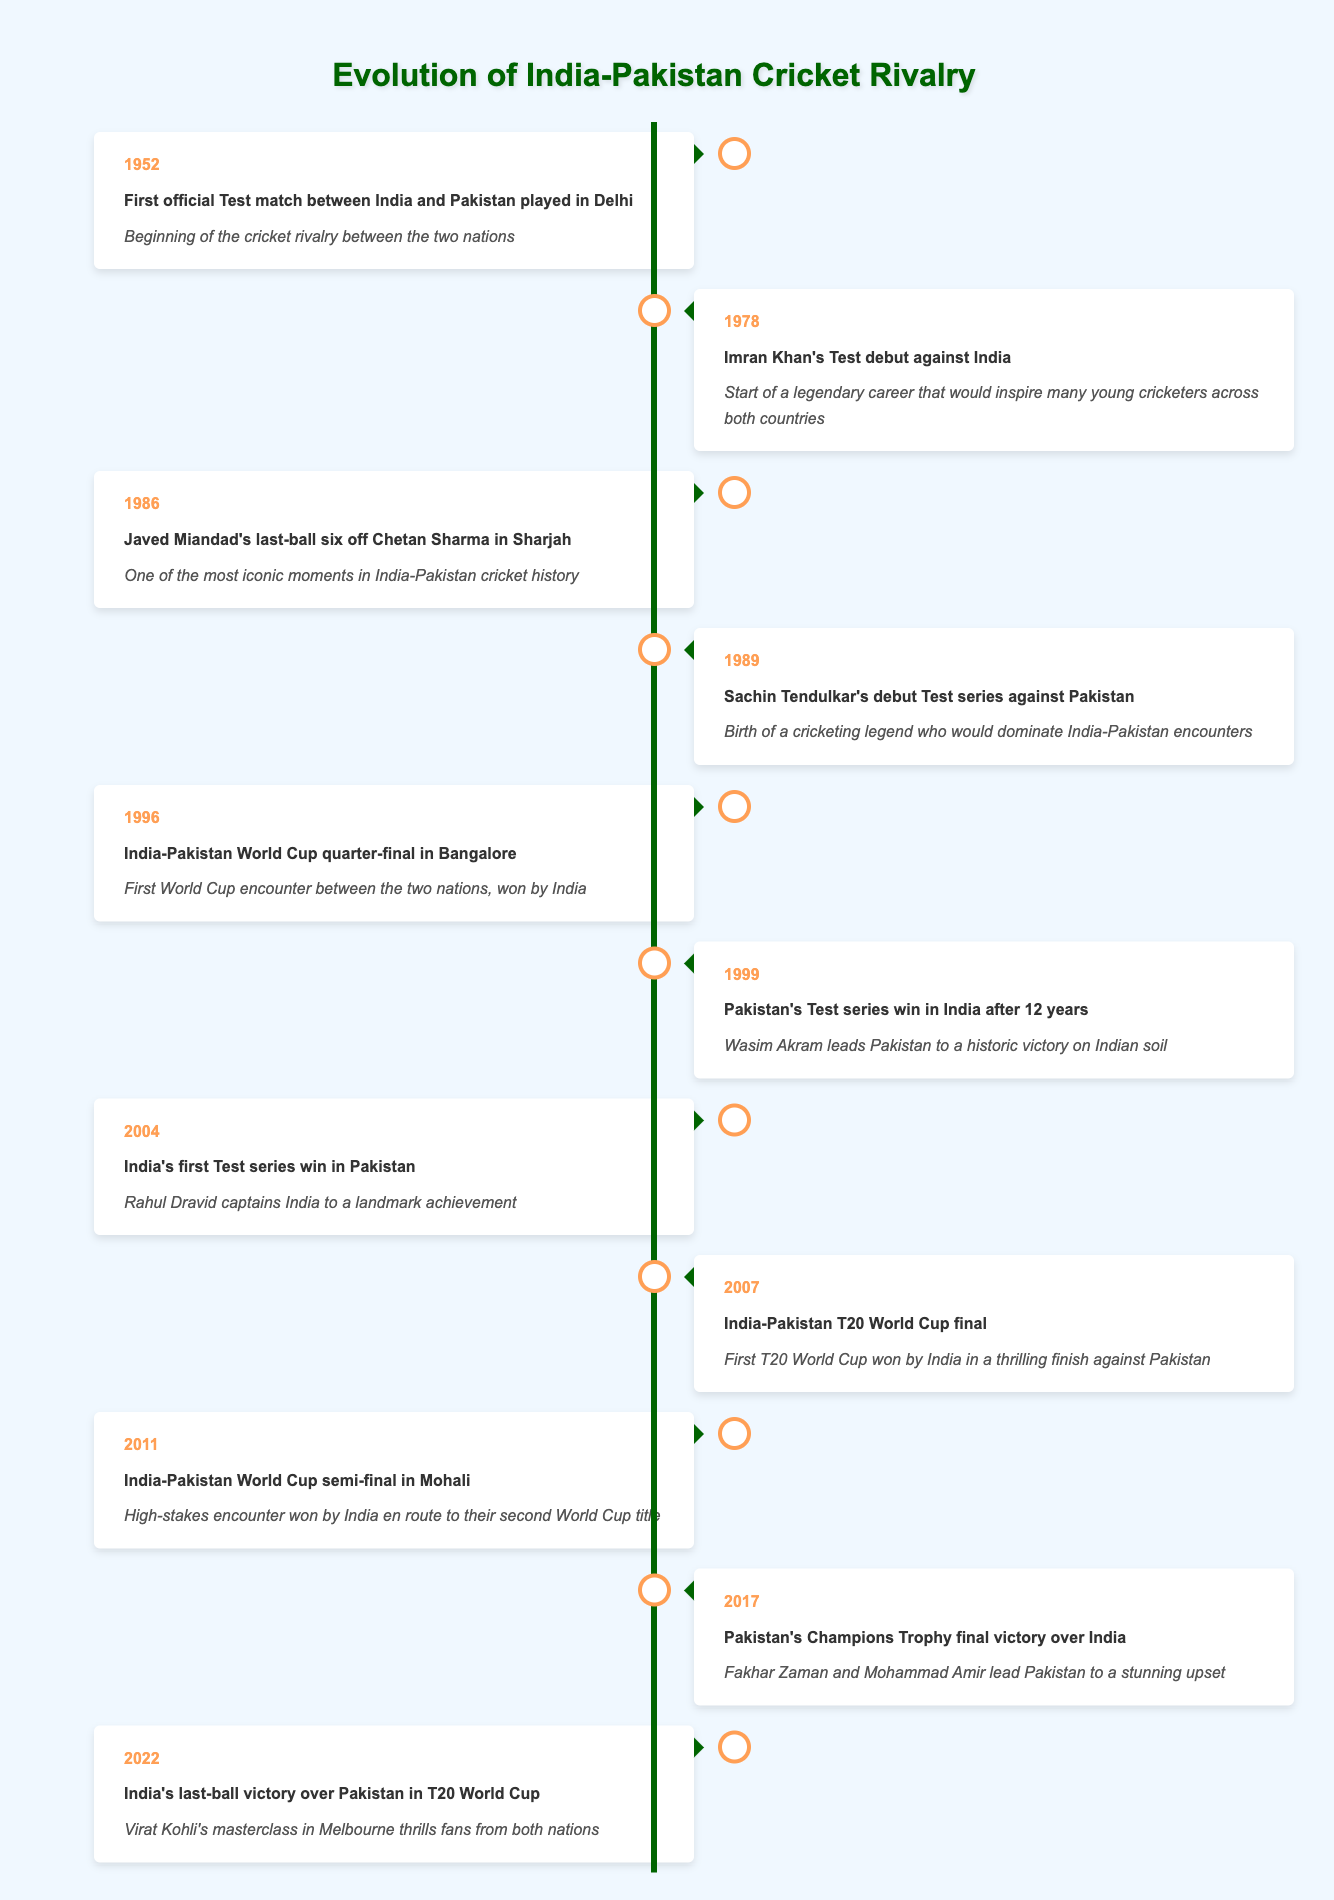What year did the first official Test match between India and Pakistan take place? The table indicates that the first official Test match between India and Pakistan was played in 1952. This information is listed in the timeline.
Answer: 1952 Who hit the last-ball six off Chetan Sharma in 1986? The timeline specifies that Javed Miandad hit the last-ball six off Chetan Sharma in 1986, making it a memorable moment in cricket history.
Answer: Javed Miandad Was Sachin Tendulkar's debut Test series against Pakistan before or after 1989? Referring to the table, Sachin Tendulkar's debut Test series against Pakistan is listed under the year 1989, which indicates that it took place in that year.
Answer: After How many years passed between India's first Test series win in Pakistan and Pakistan's Champions Trophy final victory over India? From the table, India's first Test series win in Pakistan occurred in 2004 and Pakistan's victory in the Champions Trophy final was in 2017. Therefore, 2017 - 2004 = 13 years passed between these events.
Answer: 13 In the year 1996, which match was held and what was its significance? The table shows that in 1996, the India-Pakistan World Cup quarter-final took place in Bangalore, and it was significant as it was the first World Cup encounter between the two nations, which India won.
Answer: India-Pakistan World Cup quarter-final, significance: first World Cup encounter won by India What was the outcome of the 2007 T20 World Cup final between India and Pakistan? The 2007 T20 World Cup final is described in the timeline as being won by India in a thrilling finish against Pakistan. This shows that India emerged victorious in that match.
Answer: India won List the years when India and Pakistan faced each other in World Cup matches. The table lists two World Cup matches between India and Pakistan: 1996 (quarter-final) and 2011 (semi-final). Thus, both encounters occurred in those years of the World Cups.
Answer: 1996, 2011 Is it true that Pakistan won the 2017 Champions Trophy final against India? According to the entry for the year 2017, Pakistan's Champions Trophy final victory over India is included in the timeline as a fact, confirming that they won.
Answer: Yes What were the significant events in the timeline from 1989 to 2004? The timeline includes two significant events between these years: Sachin Tendulkar's debut Test series against Pakistan in 1989 and India's first Test series win in Pakistan in 2004. They mark important developments in the rivalry and the progression of cricketing talent.
Answer: Sachin Tendulkar's debut in 1989, India's first win in Pakistan in 2004 